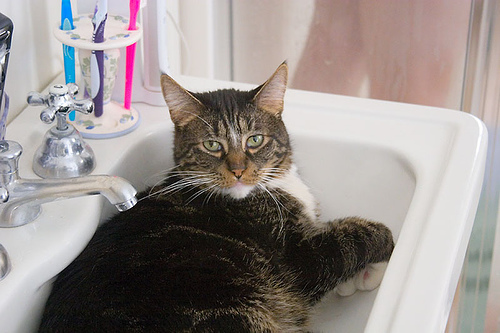<image>What color is the cup on the sink? There is no cup on the sink. What color is the cup on the sink? The cup on the sink is white. 